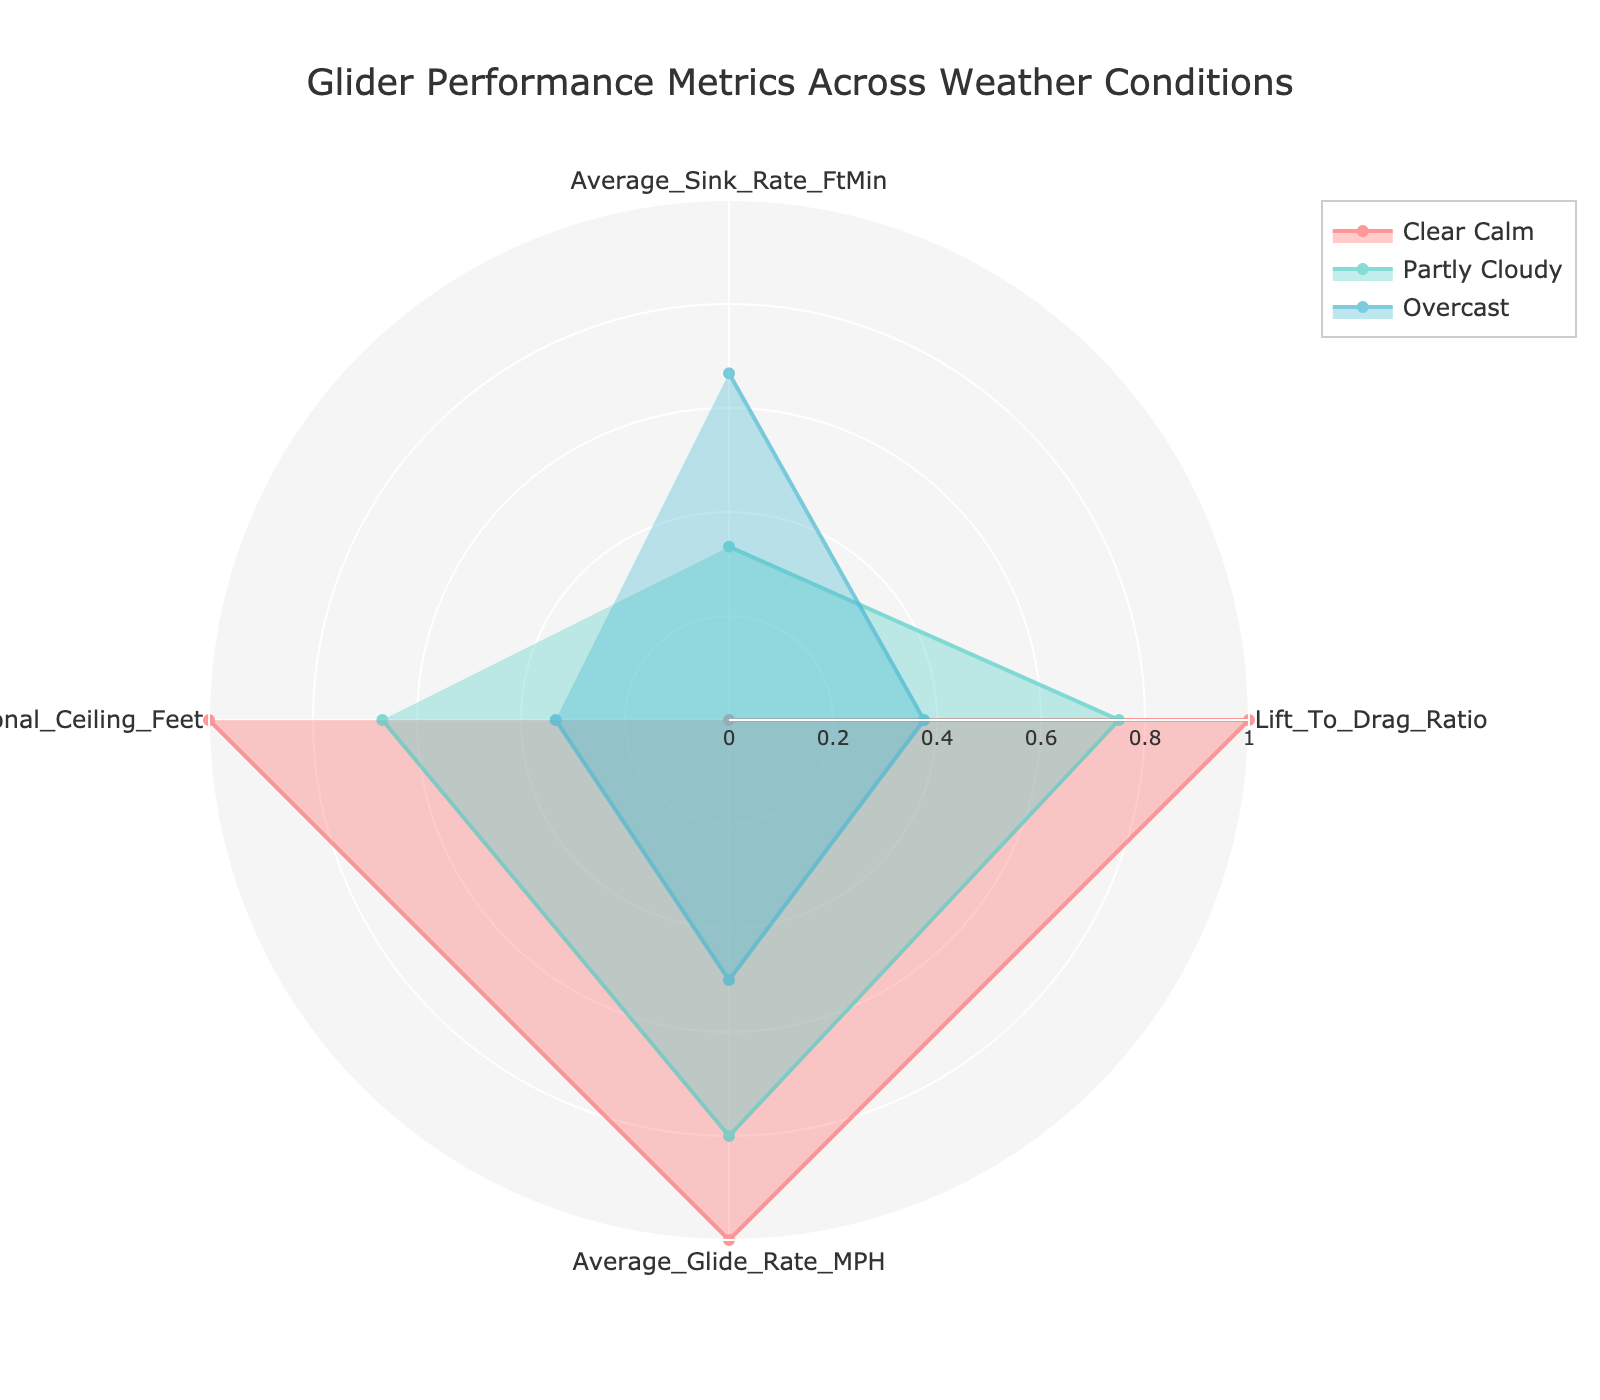What is the title of the radar chart? The title is typically found at the top of the chart and summarizes what the chart is about. Here, the title is "Glider Performance Metrics Across Weather Conditions".
Answer: Glider Performance Metrics Across Weather Conditions How many weather conditions are represented in the chart? By inspecting the legend or the different colored traces in the radar chart, we can see that there are three weather conditions represented.
Answer: Three What weather condition has the highest Average Sink Rate (Ft/Min)? To find which condition has the highest Average Sink Rate, look for the point on the radar chart's Average Sink Rate axis that is furthest from the center. Windy condition has the highest value.
Answer: Windy Which weather condition has the lowest Lift to Drag Ratio? On the Lift to Drag Ratio axis, the condition with the point closest to the center has the lowest value. This is the Windy condition.
Answer: Windy Between Clear and Partly Cloudy conditions, which has a better Average Glide Rate (MPH)? Compare the values on the Average Glide Rate axis for both conditions. Clear Calm has a better (higher) Average Glide Rate than Partly Cloudy.
Answer: Clear Calm What is the average Operational Ceiling (Feet) across the three weather conditions? To find this, sum the values of the Operational Ceilings for Clear, Partly Cloudy, and Overcast and divide by 3. Clear (10000) + Partly Cloudy (9500) + Overcast (9000) = 28500. Divide 28500 by 3 to get the average.
Answer: 9500 Which weather condition has the largest difference between the Average Sink Rate and Lift to Drag Ratio? Calculate the difference for each weather condition and compare. For Clear Calm: 120 - 40 = 80, for Partly Cloudy: 140 - 38 = 102, for Windy: 180 - 32 = 148. Windy has the largest difference.
Answer: Windy Are the Average Sink Rates for all weather conditions above or below the Lift to Drag Ratios? Compare the values of Average Sink Rates and Lift to Drag Ratios. All Average Sink Rates (120, 140, 180) are above the Lift to Drag Ratios (40, 38, 32).
Answer: Above Which metric shows the least variation across the weather conditions? Check the spread of each metric from its highest to lowest value. The Lift to Drag Ratio varies the least (from 40 to 32, a range of 8) compared to others.
Answer: Lift to Drag Ratio What is the sum of the Lift to Drag Ratios for all the weather conditions? Add the Lift to Drag Ratios for all represented conditions: 40 (Clear) + 38 (Partly Cloudy) + 35 (Overcast) + 32 (Windy) = 145.
Answer: 145 